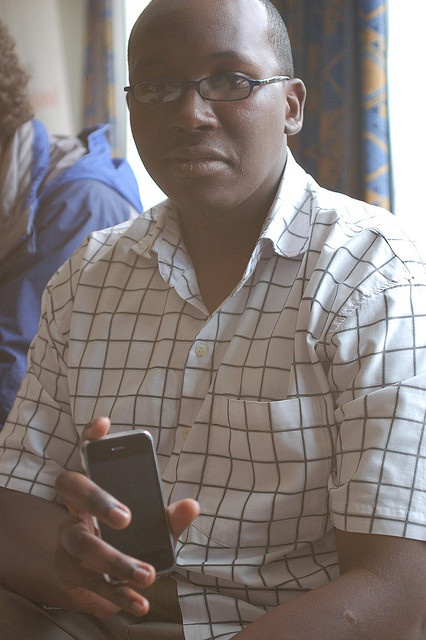Describe the objects in this image and their specific colors. I can see people in gray, maroon, and darkgray tones, people in gray and darkgray tones, and cell phone in gray and black tones in this image. 